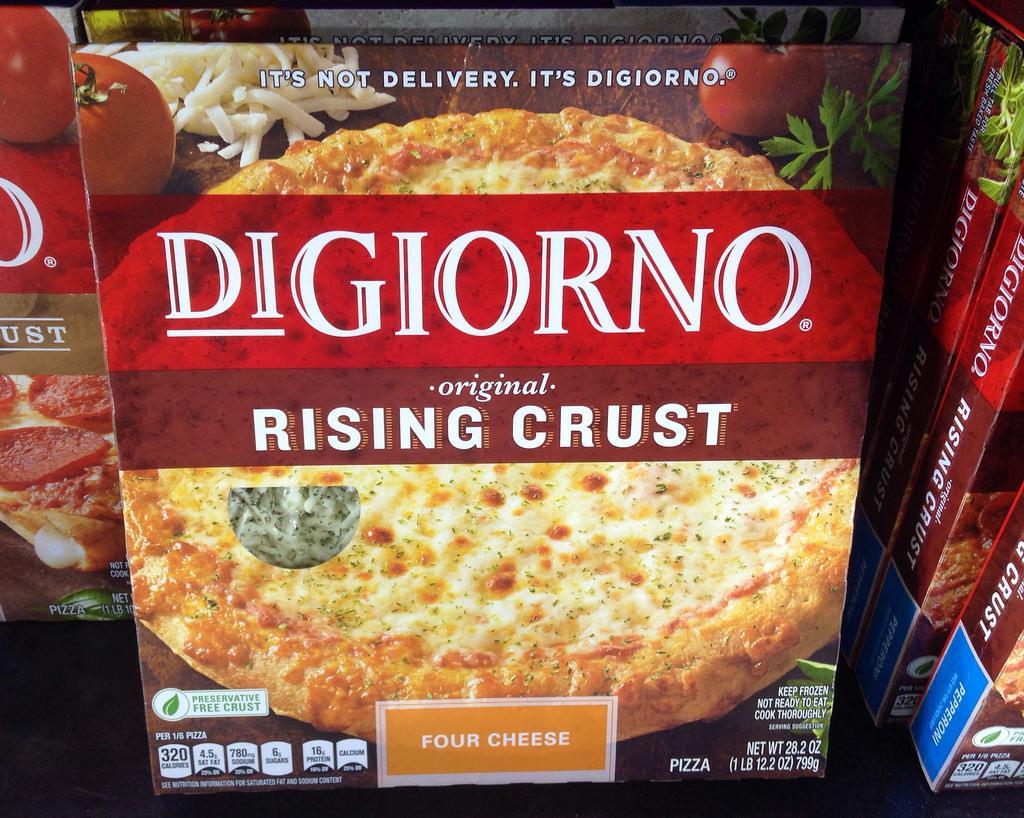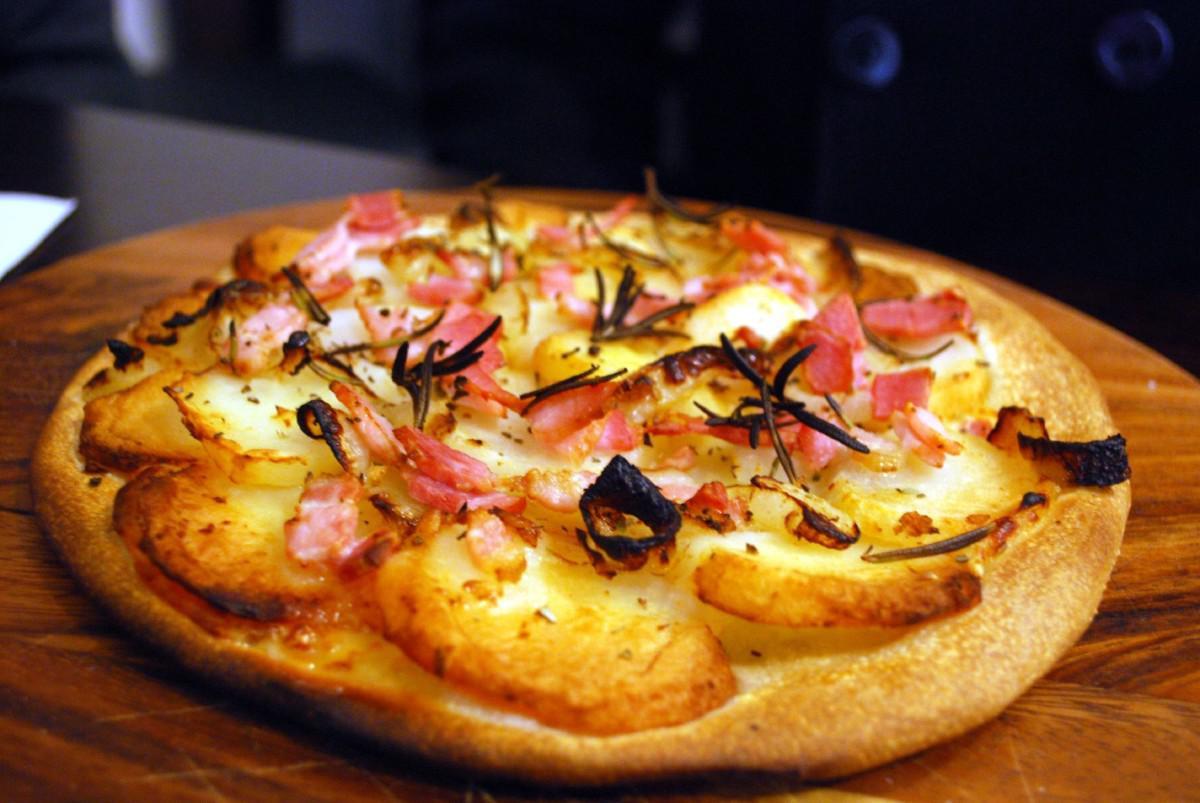The first image is the image on the left, the second image is the image on the right. Analyze the images presented: Is the assertion "All of the pizzas are cooked, whole pizzas." valid? Answer yes or no. No. The first image is the image on the left, the second image is the image on the right. For the images displayed, is the sentence "There are more pizzas in the image on the right." factually correct? Answer yes or no. No. 